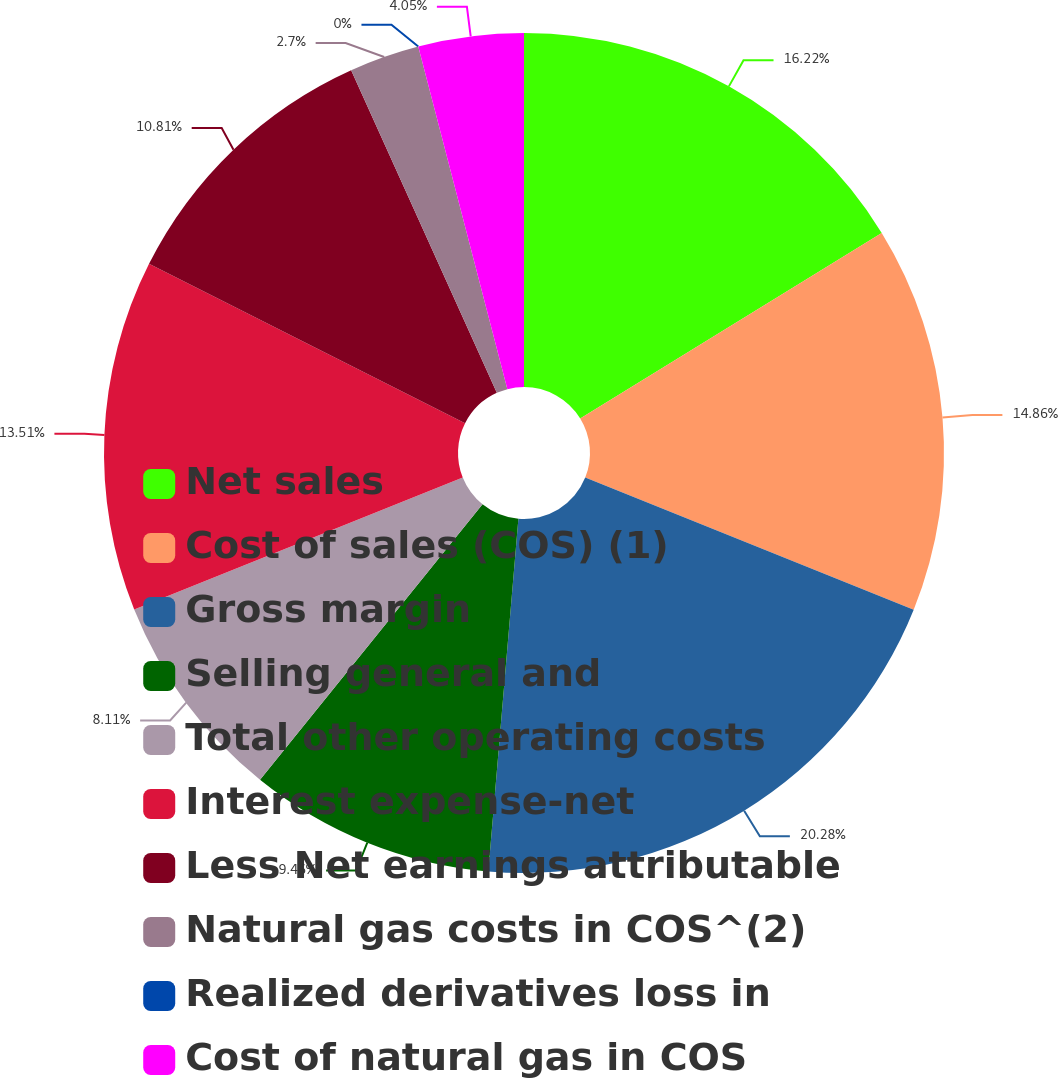<chart> <loc_0><loc_0><loc_500><loc_500><pie_chart><fcel>Net sales<fcel>Cost of sales (COS) (1)<fcel>Gross margin<fcel>Selling general and<fcel>Total other operating costs<fcel>Interest expense-net<fcel>Less Net earnings attributable<fcel>Natural gas costs in COS^(2)<fcel>Realized derivatives loss in<fcel>Cost of natural gas in COS<nl><fcel>16.22%<fcel>14.86%<fcel>20.27%<fcel>9.46%<fcel>8.11%<fcel>13.51%<fcel>10.81%<fcel>2.7%<fcel>0.0%<fcel>4.05%<nl></chart> 